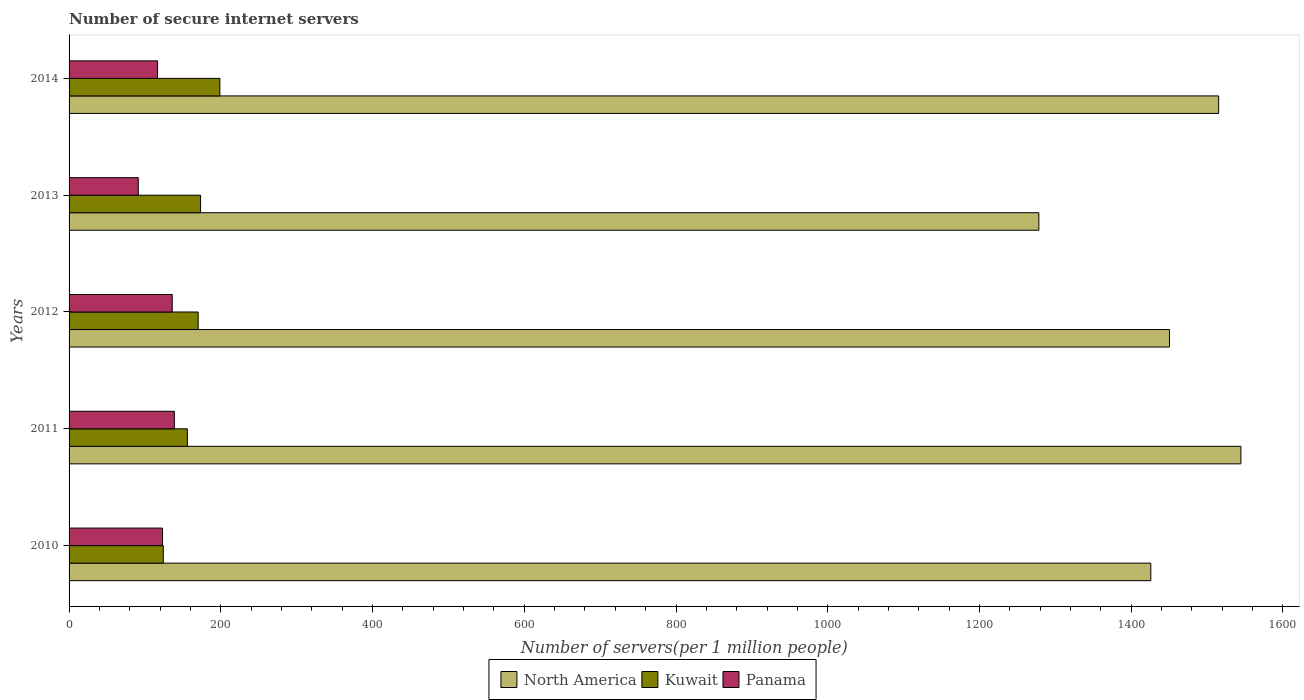How many different coloured bars are there?
Your answer should be very brief. 3. How many groups of bars are there?
Your response must be concise. 5. Are the number of bars per tick equal to the number of legend labels?
Offer a terse response. Yes. Are the number of bars on each tick of the Y-axis equal?
Your answer should be very brief. Yes. How many bars are there on the 4th tick from the bottom?
Make the answer very short. 3. What is the label of the 4th group of bars from the top?
Ensure brevity in your answer.  2011. In how many cases, is the number of bars for a given year not equal to the number of legend labels?
Provide a succinct answer. 0. What is the number of secure internet servers in North America in 2012?
Your answer should be compact. 1450.37. Across all years, what is the maximum number of secure internet servers in Kuwait?
Give a very brief answer. 198.77. Across all years, what is the minimum number of secure internet servers in Panama?
Provide a succinct answer. 91.18. In which year was the number of secure internet servers in Kuwait maximum?
Make the answer very short. 2014. In which year was the number of secure internet servers in North America minimum?
Make the answer very short. 2013. What is the total number of secure internet servers in Panama in the graph?
Your answer should be compact. 605.72. What is the difference between the number of secure internet servers in Panama in 2012 and that in 2013?
Keep it short and to the point. 44.78. What is the difference between the number of secure internet servers in North America in 2010 and the number of secure internet servers in Panama in 2012?
Give a very brief answer. 1289.8. What is the average number of secure internet servers in Panama per year?
Your answer should be very brief. 121.14. In the year 2010, what is the difference between the number of secure internet servers in Panama and number of secure internet servers in Kuwait?
Offer a very short reply. -1.02. In how many years, is the number of secure internet servers in Kuwait greater than 1440 ?
Your answer should be compact. 0. What is the ratio of the number of secure internet servers in Panama in 2010 to that in 2011?
Ensure brevity in your answer.  0.89. What is the difference between the highest and the second highest number of secure internet servers in North America?
Make the answer very short. 29.33. What is the difference between the highest and the lowest number of secure internet servers in Kuwait?
Your answer should be very brief. 74.56. In how many years, is the number of secure internet servers in Kuwait greater than the average number of secure internet servers in Kuwait taken over all years?
Make the answer very short. 3. What does the 1st bar from the top in 2013 represents?
Offer a terse response. Panama. Is it the case that in every year, the sum of the number of secure internet servers in Panama and number of secure internet servers in North America is greater than the number of secure internet servers in Kuwait?
Provide a short and direct response. Yes. How many bars are there?
Provide a short and direct response. 15. What is the difference between two consecutive major ticks on the X-axis?
Your response must be concise. 200. Where does the legend appear in the graph?
Provide a succinct answer. Bottom center. How many legend labels are there?
Provide a succinct answer. 3. What is the title of the graph?
Your answer should be compact. Number of secure internet servers. Does "Cameroon" appear as one of the legend labels in the graph?
Your answer should be very brief. No. What is the label or title of the X-axis?
Provide a short and direct response. Number of servers(per 1 million people). What is the label or title of the Y-axis?
Offer a terse response. Years. What is the Number of servers(per 1 million people) of North America in 2010?
Your response must be concise. 1425.76. What is the Number of servers(per 1 million people) of Kuwait in 2010?
Offer a very short reply. 124.2. What is the Number of servers(per 1 million people) in Panama in 2010?
Provide a short and direct response. 123.19. What is the Number of servers(per 1 million people) in North America in 2011?
Ensure brevity in your answer.  1544.53. What is the Number of servers(per 1 million people) in Kuwait in 2011?
Your answer should be very brief. 155.9. What is the Number of servers(per 1 million people) in Panama in 2011?
Offer a very short reply. 138.78. What is the Number of servers(per 1 million people) in North America in 2012?
Offer a very short reply. 1450.37. What is the Number of servers(per 1 million people) in Kuwait in 2012?
Give a very brief answer. 170.2. What is the Number of servers(per 1 million people) in Panama in 2012?
Your answer should be very brief. 135.96. What is the Number of servers(per 1 million people) in North America in 2013?
Keep it short and to the point. 1278.21. What is the Number of servers(per 1 million people) of Kuwait in 2013?
Your answer should be very brief. 173.36. What is the Number of servers(per 1 million people) of Panama in 2013?
Offer a very short reply. 91.18. What is the Number of servers(per 1 million people) of North America in 2014?
Keep it short and to the point. 1515.2. What is the Number of servers(per 1 million people) of Kuwait in 2014?
Provide a succinct answer. 198.77. What is the Number of servers(per 1 million people) in Panama in 2014?
Your answer should be very brief. 116.61. Across all years, what is the maximum Number of servers(per 1 million people) of North America?
Your response must be concise. 1544.53. Across all years, what is the maximum Number of servers(per 1 million people) of Kuwait?
Offer a terse response. 198.77. Across all years, what is the maximum Number of servers(per 1 million people) of Panama?
Your response must be concise. 138.78. Across all years, what is the minimum Number of servers(per 1 million people) of North America?
Your answer should be compact. 1278.21. Across all years, what is the minimum Number of servers(per 1 million people) in Kuwait?
Keep it short and to the point. 124.2. Across all years, what is the minimum Number of servers(per 1 million people) in Panama?
Provide a short and direct response. 91.18. What is the total Number of servers(per 1 million people) in North America in the graph?
Make the answer very short. 7214.08. What is the total Number of servers(per 1 million people) in Kuwait in the graph?
Provide a succinct answer. 822.43. What is the total Number of servers(per 1 million people) of Panama in the graph?
Offer a very short reply. 605.72. What is the difference between the Number of servers(per 1 million people) in North America in 2010 and that in 2011?
Provide a short and direct response. -118.77. What is the difference between the Number of servers(per 1 million people) in Kuwait in 2010 and that in 2011?
Your response must be concise. -31.7. What is the difference between the Number of servers(per 1 million people) of Panama in 2010 and that in 2011?
Ensure brevity in your answer.  -15.6. What is the difference between the Number of servers(per 1 million people) of North America in 2010 and that in 2012?
Offer a very short reply. -24.61. What is the difference between the Number of servers(per 1 million people) in Kuwait in 2010 and that in 2012?
Provide a succinct answer. -45.99. What is the difference between the Number of servers(per 1 million people) of Panama in 2010 and that in 2012?
Your answer should be very brief. -12.77. What is the difference between the Number of servers(per 1 million people) of North America in 2010 and that in 2013?
Make the answer very short. 147.55. What is the difference between the Number of servers(per 1 million people) in Kuwait in 2010 and that in 2013?
Make the answer very short. -49.16. What is the difference between the Number of servers(per 1 million people) in Panama in 2010 and that in 2013?
Provide a short and direct response. 32.01. What is the difference between the Number of servers(per 1 million people) of North America in 2010 and that in 2014?
Ensure brevity in your answer.  -89.44. What is the difference between the Number of servers(per 1 million people) in Kuwait in 2010 and that in 2014?
Ensure brevity in your answer.  -74.56. What is the difference between the Number of servers(per 1 million people) of Panama in 2010 and that in 2014?
Ensure brevity in your answer.  6.58. What is the difference between the Number of servers(per 1 million people) of North America in 2011 and that in 2012?
Your response must be concise. 94.16. What is the difference between the Number of servers(per 1 million people) of Kuwait in 2011 and that in 2012?
Your answer should be very brief. -14.29. What is the difference between the Number of servers(per 1 million people) in Panama in 2011 and that in 2012?
Offer a terse response. 2.82. What is the difference between the Number of servers(per 1 million people) in North America in 2011 and that in 2013?
Give a very brief answer. 266.32. What is the difference between the Number of servers(per 1 million people) in Kuwait in 2011 and that in 2013?
Provide a short and direct response. -17.46. What is the difference between the Number of servers(per 1 million people) of Panama in 2011 and that in 2013?
Provide a short and direct response. 47.6. What is the difference between the Number of servers(per 1 million people) in North America in 2011 and that in 2014?
Make the answer very short. 29.33. What is the difference between the Number of servers(per 1 million people) in Kuwait in 2011 and that in 2014?
Keep it short and to the point. -42.86. What is the difference between the Number of servers(per 1 million people) in Panama in 2011 and that in 2014?
Keep it short and to the point. 22.17. What is the difference between the Number of servers(per 1 million people) of North America in 2012 and that in 2013?
Your answer should be compact. 172.16. What is the difference between the Number of servers(per 1 million people) in Kuwait in 2012 and that in 2013?
Give a very brief answer. -3.16. What is the difference between the Number of servers(per 1 million people) of Panama in 2012 and that in 2013?
Give a very brief answer. 44.78. What is the difference between the Number of servers(per 1 million people) of North America in 2012 and that in 2014?
Your answer should be very brief. -64.83. What is the difference between the Number of servers(per 1 million people) in Kuwait in 2012 and that in 2014?
Your response must be concise. -28.57. What is the difference between the Number of servers(per 1 million people) of Panama in 2012 and that in 2014?
Provide a succinct answer. 19.35. What is the difference between the Number of servers(per 1 million people) in North America in 2013 and that in 2014?
Ensure brevity in your answer.  -236.99. What is the difference between the Number of servers(per 1 million people) in Kuwait in 2013 and that in 2014?
Your response must be concise. -25.41. What is the difference between the Number of servers(per 1 million people) in Panama in 2013 and that in 2014?
Provide a succinct answer. -25.43. What is the difference between the Number of servers(per 1 million people) of North America in 2010 and the Number of servers(per 1 million people) of Kuwait in 2011?
Provide a short and direct response. 1269.86. What is the difference between the Number of servers(per 1 million people) of North America in 2010 and the Number of servers(per 1 million people) of Panama in 2011?
Give a very brief answer. 1286.98. What is the difference between the Number of servers(per 1 million people) of Kuwait in 2010 and the Number of servers(per 1 million people) of Panama in 2011?
Keep it short and to the point. -14.58. What is the difference between the Number of servers(per 1 million people) of North America in 2010 and the Number of servers(per 1 million people) of Kuwait in 2012?
Your response must be concise. 1255.56. What is the difference between the Number of servers(per 1 million people) in North America in 2010 and the Number of servers(per 1 million people) in Panama in 2012?
Keep it short and to the point. 1289.8. What is the difference between the Number of servers(per 1 million people) of Kuwait in 2010 and the Number of servers(per 1 million people) of Panama in 2012?
Give a very brief answer. -11.76. What is the difference between the Number of servers(per 1 million people) in North America in 2010 and the Number of servers(per 1 million people) in Kuwait in 2013?
Provide a short and direct response. 1252.4. What is the difference between the Number of servers(per 1 million people) in North America in 2010 and the Number of servers(per 1 million people) in Panama in 2013?
Provide a short and direct response. 1334.58. What is the difference between the Number of servers(per 1 million people) in Kuwait in 2010 and the Number of servers(per 1 million people) in Panama in 2013?
Your answer should be very brief. 33.02. What is the difference between the Number of servers(per 1 million people) in North America in 2010 and the Number of servers(per 1 million people) in Kuwait in 2014?
Your answer should be very brief. 1226.99. What is the difference between the Number of servers(per 1 million people) of North America in 2010 and the Number of servers(per 1 million people) of Panama in 2014?
Your answer should be compact. 1309.15. What is the difference between the Number of servers(per 1 million people) in Kuwait in 2010 and the Number of servers(per 1 million people) in Panama in 2014?
Give a very brief answer. 7.59. What is the difference between the Number of servers(per 1 million people) of North America in 2011 and the Number of servers(per 1 million people) of Kuwait in 2012?
Your answer should be very brief. 1374.33. What is the difference between the Number of servers(per 1 million people) of North America in 2011 and the Number of servers(per 1 million people) of Panama in 2012?
Ensure brevity in your answer.  1408.57. What is the difference between the Number of servers(per 1 million people) in Kuwait in 2011 and the Number of servers(per 1 million people) in Panama in 2012?
Your answer should be very brief. 19.94. What is the difference between the Number of servers(per 1 million people) in North America in 2011 and the Number of servers(per 1 million people) in Kuwait in 2013?
Your answer should be very brief. 1371.17. What is the difference between the Number of servers(per 1 million people) of North America in 2011 and the Number of servers(per 1 million people) of Panama in 2013?
Offer a terse response. 1453.35. What is the difference between the Number of servers(per 1 million people) in Kuwait in 2011 and the Number of servers(per 1 million people) in Panama in 2013?
Keep it short and to the point. 64.72. What is the difference between the Number of servers(per 1 million people) of North America in 2011 and the Number of servers(per 1 million people) of Kuwait in 2014?
Provide a short and direct response. 1345.76. What is the difference between the Number of servers(per 1 million people) in North America in 2011 and the Number of servers(per 1 million people) in Panama in 2014?
Keep it short and to the point. 1427.92. What is the difference between the Number of servers(per 1 million people) of Kuwait in 2011 and the Number of servers(per 1 million people) of Panama in 2014?
Make the answer very short. 39.29. What is the difference between the Number of servers(per 1 million people) of North America in 2012 and the Number of servers(per 1 million people) of Kuwait in 2013?
Your response must be concise. 1277.02. What is the difference between the Number of servers(per 1 million people) of North America in 2012 and the Number of servers(per 1 million people) of Panama in 2013?
Provide a succinct answer. 1359.2. What is the difference between the Number of servers(per 1 million people) of Kuwait in 2012 and the Number of servers(per 1 million people) of Panama in 2013?
Your answer should be very brief. 79.02. What is the difference between the Number of servers(per 1 million people) in North America in 2012 and the Number of servers(per 1 million people) in Kuwait in 2014?
Provide a short and direct response. 1251.61. What is the difference between the Number of servers(per 1 million people) of North America in 2012 and the Number of servers(per 1 million people) of Panama in 2014?
Your response must be concise. 1333.76. What is the difference between the Number of servers(per 1 million people) in Kuwait in 2012 and the Number of servers(per 1 million people) in Panama in 2014?
Provide a short and direct response. 53.58. What is the difference between the Number of servers(per 1 million people) of North America in 2013 and the Number of servers(per 1 million people) of Kuwait in 2014?
Your answer should be very brief. 1079.44. What is the difference between the Number of servers(per 1 million people) in North America in 2013 and the Number of servers(per 1 million people) in Panama in 2014?
Your answer should be compact. 1161.6. What is the difference between the Number of servers(per 1 million people) in Kuwait in 2013 and the Number of servers(per 1 million people) in Panama in 2014?
Make the answer very short. 56.75. What is the average Number of servers(per 1 million people) of North America per year?
Your response must be concise. 1442.82. What is the average Number of servers(per 1 million people) in Kuwait per year?
Your response must be concise. 164.49. What is the average Number of servers(per 1 million people) in Panama per year?
Ensure brevity in your answer.  121.14. In the year 2010, what is the difference between the Number of servers(per 1 million people) of North America and Number of servers(per 1 million people) of Kuwait?
Keep it short and to the point. 1301.56. In the year 2010, what is the difference between the Number of servers(per 1 million people) in North America and Number of servers(per 1 million people) in Panama?
Make the answer very short. 1302.57. In the year 2010, what is the difference between the Number of servers(per 1 million people) in Kuwait and Number of servers(per 1 million people) in Panama?
Give a very brief answer. 1.02. In the year 2011, what is the difference between the Number of servers(per 1 million people) in North America and Number of servers(per 1 million people) in Kuwait?
Offer a very short reply. 1388.63. In the year 2011, what is the difference between the Number of servers(per 1 million people) of North America and Number of servers(per 1 million people) of Panama?
Provide a succinct answer. 1405.75. In the year 2011, what is the difference between the Number of servers(per 1 million people) in Kuwait and Number of servers(per 1 million people) in Panama?
Offer a very short reply. 17.12. In the year 2012, what is the difference between the Number of servers(per 1 million people) of North America and Number of servers(per 1 million people) of Kuwait?
Make the answer very short. 1280.18. In the year 2012, what is the difference between the Number of servers(per 1 million people) of North America and Number of servers(per 1 million people) of Panama?
Provide a succinct answer. 1314.42. In the year 2012, what is the difference between the Number of servers(per 1 million people) in Kuwait and Number of servers(per 1 million people) in Panama?
Offer a terse response. 34.24. In the year 2013, what is the difference between the Number of servers(per 1 million people) of North America and Number of servers(per 1 million people) of Kuwait?
Ensure brevity in your answer.  1104.85. In the year 2013, what is the difference between the Number of servers(per 1 million people) in North America and Number of servers(per 1 million people) in Panama?
Your response must be concise. 1187.03. In the year 2013, what is the difference between the Number of servers(per 1 million people) of Kuwait and Number of servers(per 1 million people) of Panama?
Your answer should be very brief. 82.18. In the year 2014, what is the difference between the Number of servers(per 1 million people) in North America and Number of servers(per 1 million people) in Kuwait?
Offer a terse response. 1316.44. In the year 2014, what is the difference between the Number of servers(per 1 million people) in North America and Number of servers(per 1 million people) in Panama?
Ensure brevity in your answer.  1398.59. In the year 2014, what is the difference between the Number of servers(per 1 million people) in Kuwait and Number of servers(per 1 million people) in Panama?
Provide a succinct answer. 82.16. What is the ratio of the Number of servers(per 1 million people) of Kuwait in 2010 to that in 2011?
Provide a succinct answer. 0.8. What is the ratio of the Number of servers(per 1 million people) of Panama in 2010 to that in 2011?
Offer a very short reply. 0.89. What is the ratio of the Number of servers(per 1 million people) in North America in 2010 to that in 2012?
Keep it short and to the point. 0.98. What is the ratio of the Number of servers(per 1 million people) in Kuwait in 2010 to that in 2012?
Your response must be concise. 0.73. What is the ratio of the Number of servers(per 1 million people) of Panama in 2010 to that in 2012?
Provide a succinct answer. 0.91. What is the ratio of the Number of servers(per 1 million people) of North America in 2010 to that in 2013?
Your answer should be very brief. 1.12. What is the ratio of the Number of servers(per 1 million people) of Kuwait in 2010 to that in 2013?
Offer a terse response. 0.72. What is the ratio of the Number of servers(per 1 million people) in Panama in 2010 to that in 2013?
Provide a succinct answer. 1.35. What is the ratio of the Number of servers(per 1 million people) in North America in 2010 to that in 2014?
Your answer should be compact. 0.94. What is the ratio of the Number of servers(per 1 million people) of Kuwait in 2010 to that in 2014?
Give a very brief answer. 0.62. What is the ratio of the Number of servers(per 1 million people) in Panama in 2010 to that in 2014?
Give a very brief answer. 1.06. What is the ratio of the Number of servers(per 1 million people) of North America in 2011 to that in 2012?
Ensure brevity in your answer.  1.06. What is the ratio of the Number of servers(per 1 million people) of Kuwait in 2011 to that in 2012?
Make the answer very short. 0.92. What is the ratio of the Number of servers(per 1 million people) of Panama in 2011 to that in 2012?
Offer a terse response. 1.02. What is the ratio of the Number of servers(per 1 million people) in North America in 2011 to that in 2013?
Ensure brevity in your answer.  1.21. What is the ratio of the Number of servers(per 1 million people) in Kuwait in 2011 to that in 2013?
Your answer should be compact. 0.9. What is the ratio of the Number of servers(per 1 million people) in Panama in 2011 to that in 2013?
Give a very brief answer. 1.52. What is the ratio of the Number of servers(per 1 million people) in North America in 2011 to that in 2014?
Make the answer very short. 1.02. What is the ratio of the Number of servers(per 1 million people) of Kuwait in 2011 to that in 2014?
Make the answer very short. 0.78. What is the ratio of the Number of servers(per 1 million people) in Panama in 2011 to that in 2014?
Keep it short and to the point. 1.19. What is the ratio of the Number of servers(per 1 million people) in North America in 2012 to that in 2013?
Offer a terse response. 1.13. What is the ratio of the Number of servers(per 1 million people) of Kuwait in 2012 to that in 2013?
Give a very brief answer. 0.98. What is the ratio of the Number of servers(per 1 million people) of Panama in 2012 to that in 2013?
Make the answer very short. 1.49. What is the ratio of the Number of servers(per 1 million people) in North America in 2012 to that in 2014?
Your answer should be compact. 0.96. What is the ratio of the Number of servers(per 1 million people) of Kuwait in 2012 to that in 2014?
Keep it short and to the point. 0.86. What is the ratio of the Number of servers(per 1 million people) of Panama in 2012 to that in 2014?
Offer a very short reply. 1.17. What is the ratio of the Number of servers(per 1 million people) in North America in 2013 to that in 2014?
Offer a very short reply. 0.84. What is the ratio of the Number of servers(per 1 million people) in Kuwait in 2013 to that in 2014?
Your answer should be compact. 0.87. What is the ratio of the Number of servers(per 1 million people) of Panama in 2013 to that in 2014?
Keep it short and to the point. 0.78. What is the difference between the highest and the second highest Number of servers(per 1 million people) in North America?
Ensure brevity in your answer.  29.33. What is the difference between the highest and the second highest Number of servers(per 1 million people) of Kuwait?
Your response must be concise. 25.41. What is the difference between the highest and the second highest Number of servers(per 1 million people) of Panama?
Provide a succinct answer. 2.82. What is the difference between the highest and the lowest Number of servers(per 1 million people) in North America?
Provide a succinct answer. 266.32. What is the difference between the highest and the lowest Number of servers(per 1 million people) of Kuwait?
Keep it short and to the point. 74.56. What is the difference between the highest and the lowest Number of servers(per 1 million people) in Panama?
Offer a terse response. 47.6. 